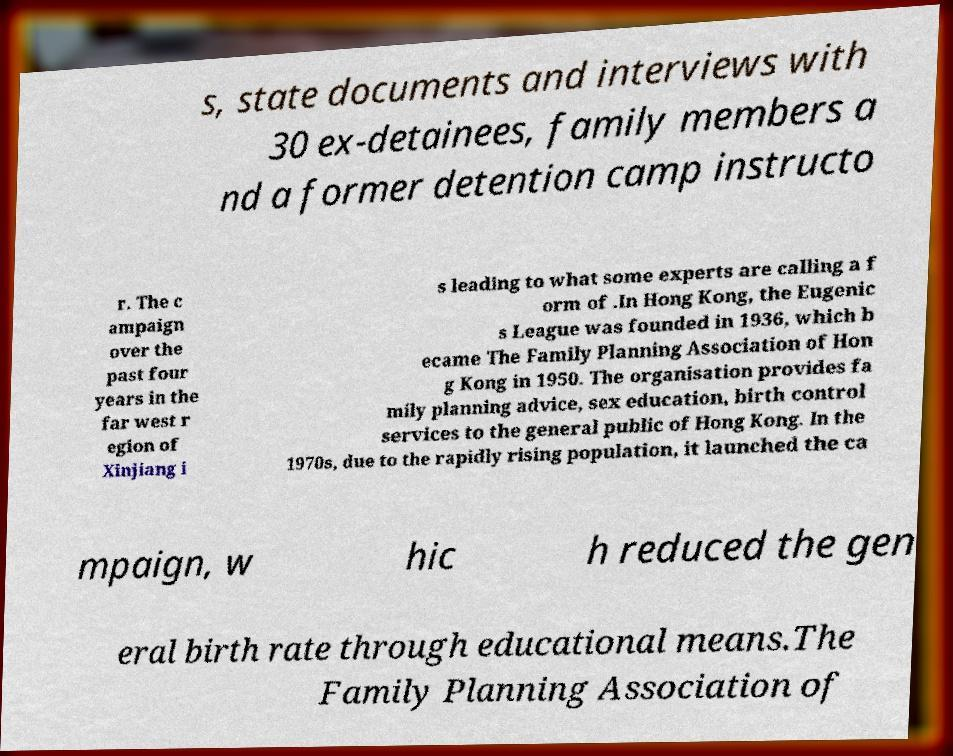Please read and relay the text visible in this image. What does it say? s, state documents and interviews with 30 ex-detainees, family members a nd a former detention camp instructo r. The c ampaign over the past four years in the far west r egion of Xinjiang i s leading to what some experts are calling a f orm of .In Hong Kong, the Eugenic s League was founded in 1936, which b ecame The Family Planning Association of Hon g Kong in 1950. The organisation provides fa mily planning advice, sex education, birth control services to the general public of Hong Kong. In the 1970s, due to the rapidly rising population, it launched the ca mpaign, w hic h reduced the gen eral birth rate through educational means.The Family Planning Association of 